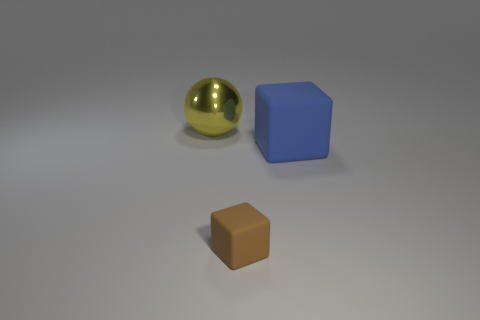Add 2 large blue metallic cylinders. How many objects exist? 5 Subtract all spheres. How many objects are left? 2 Subtract 0 gray cylinders. How many objects are left? 3 Subtract all large blue rubber cylinders. Subtract all brown matte blocks. How many objects are left? 2 Add 1 big spheres. How many big spheres are left? 2 Add 1 red cylinders. How many red cylinders exist? 1 